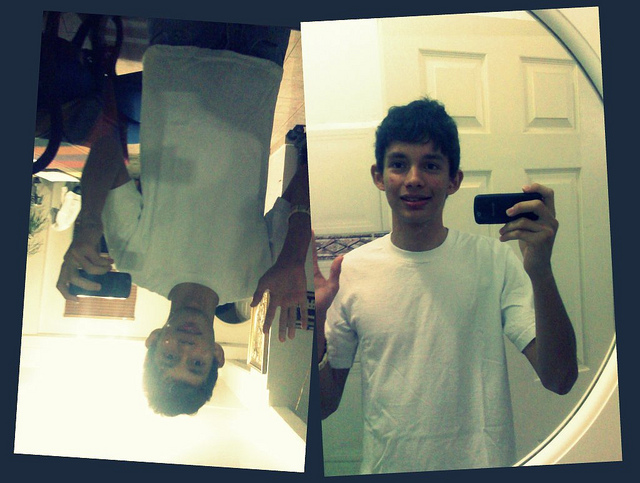What kind of creative activities can you imagine taking place in this room? In this room, a variety of creative activities could take place. The person might experiment with different photography techniques, using the mirror to capture unique reflections and angles. They could also engage in sketching or painting, inspired by their environment and personal experiences. Writing could be another activity, with the room providing a quiet space for journaling or crafting stories. Additionally, playing a musical instrument or composing music could occur here, with the serene setting fostering a conducive atmosphere for creativity. 